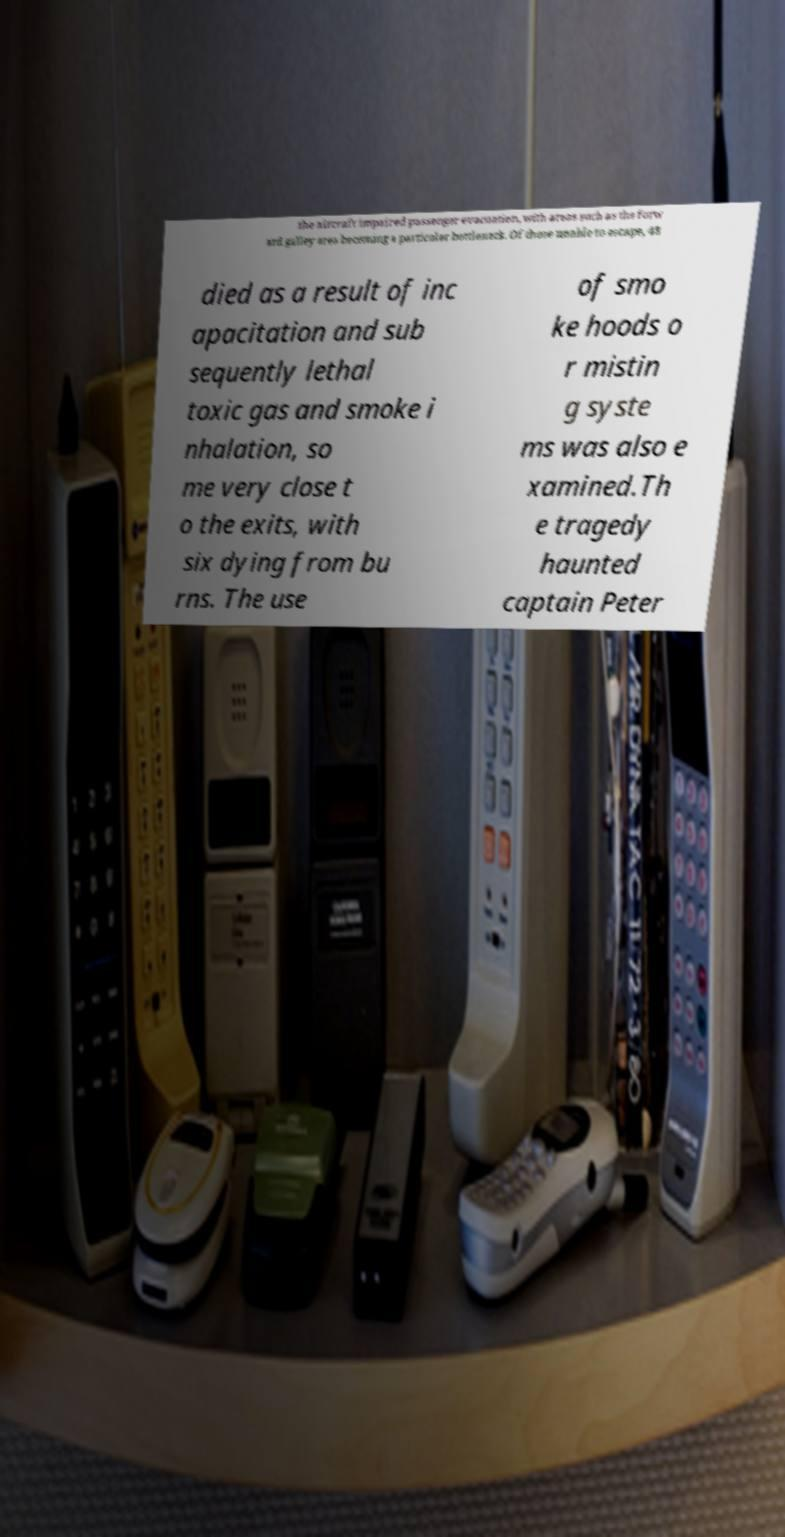There's text embedded in this image that I need extracted. Can you transcribe it verbatim? the aircraft impaired passenger evacuation, with areas such as the forw ard galley area becoming a particular bottleneck. Of those unable to escape, 48 died as a result of inc apacitation and sub sequently lethal toxic gas and smoke i nhalation, so me very close t o the exits, with six dying from bu rns. The use of smo ke hoods o r mistin g syste ms was also e xamined.Th e tragedy haunted captain Peter 